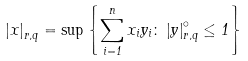<formula> <loc_0><loc_0><loc_500><loc_500>\left | x \right | _ { r , q } = \sup \left \{ \sum _ { i = 1 } ^ { n } x _ { i } y _ { i } \colon \left | y \right | _ { r , q } ^ { \circ } \leq 1 \right \}</formula> 